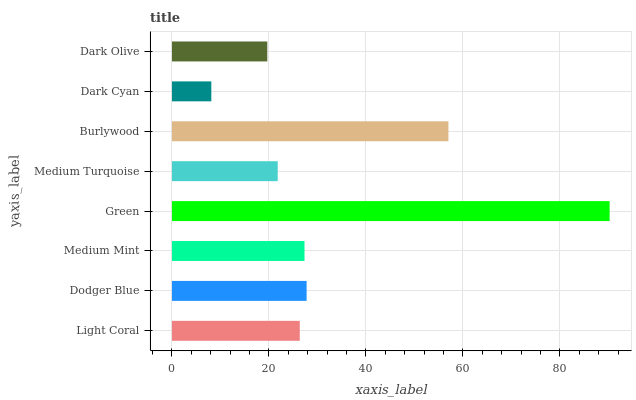Is Dark Cyan the minimum?
Answer yes or no. Yes. Is Green the maximum?
Answer yes or no. Yes. Is Dodger Blue the minimum?
Answer yes or no. No. Is Dodger Blue the maximum?
Answer yes or no. No. Is Dodger Blue greater than Light Coral?
Answer yes or no. Yes. Is Light Coral less than Dodger Blue?
Answer yes or no. Yes. Is Light Coral greater than Dodger Blue?
Answer yes or no. No. Is Dodger Blue less than Light Coral?
Answer yes or no. No. Is Medium Mint the high median?
Answer yes or no. Yes. Is Light Coral the low median?
Answer yes or no. Yes. Is Green the high median?
Answer yes or no. No. Is Burlywood the low median?
Answer yes or no. No. 